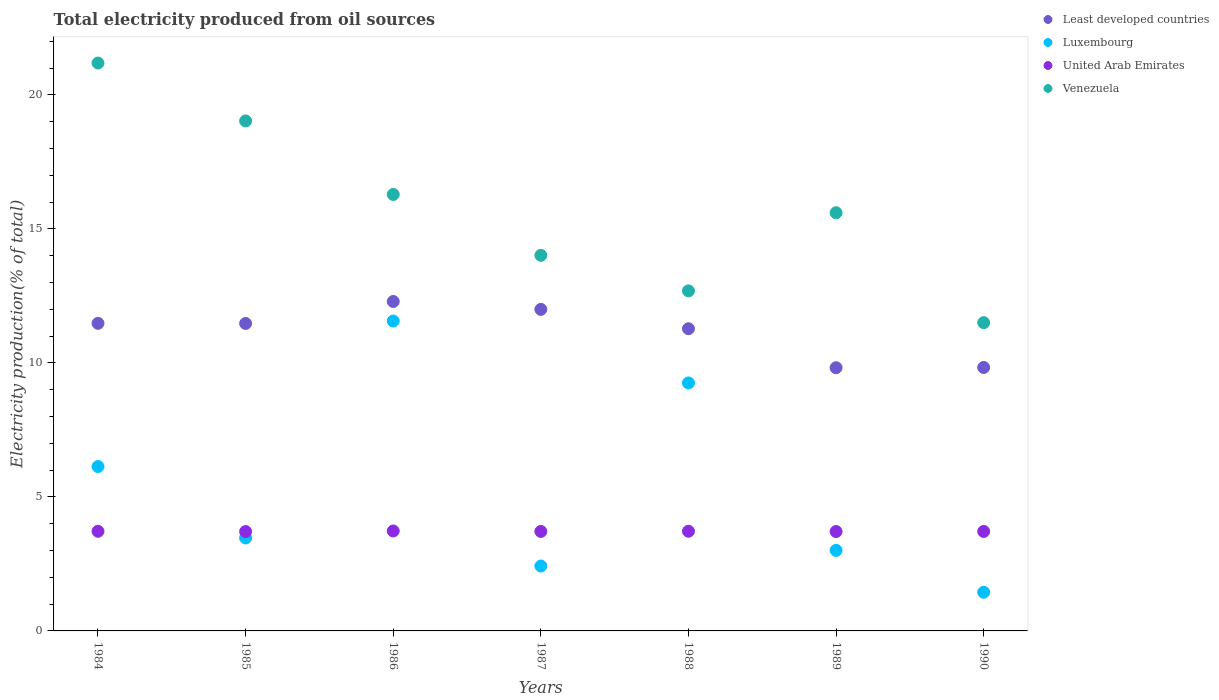What is the total electricity produced in Luxembourg in 1987?
Keep it short and to the point. 2.42. Across all years, what is the maximum total electricity produced in Luxembourg?
Make the answer very short. 11.56. Across all years, what is the minimum total electricity produced in Least developed countries?
Offer a terse response. 9.82. In which year was the total electricity produced in Least developed countries minimum?
Provide a succinct answer. 1989. What is the total total electricity produced in Luxembourg in the graph?
Offer a terse response. 37.29. What is the difference between the total electricity produced in Venezuela in 1984 and that in 1988?
Provide a short and direct response. 8.5. What is the difference between the total electricity produced in Least developed countries in 1985 and the total electricity produced in Venezuela in 1989?
Your answer should be compact. -4.13. What is the average total electricity produced in Venezuela per year?
Offer a terse response. 15.76. In the year 1986, what is the difference between the total electricity produced in Venezuela and total electricity produced in United Arab Emirates?
Your response must be concise. 12.56. What is the ratio of the total electricity produced in United Arab Emirates in 1984 to that in 1989?
Ensure brevity in your answer.  1. Is the difference between the total electricity produced in Venezuela in 1984 and 1990 greater than the difference between the total electricity produced in United Arab Emirates in 1984 and 1990?
Offer a terse response. Yes. What is the difference between the highest and the second highest total electricity produced in Luxembourg?
Your answer should be compact. 2.31. What is the difference between the highest and the lowest total electricity produced in Luxembourg?
Give a very brief answer. 10.12. In how many years, is the total electricity produced in Least developed countries greater than the average total electricity produced in Least developed countries taken over all years?
Ensure brevity in your answer.  5. Is the sum of the total electricity produced in Venezuela in 1985 and 1987 greater than the maximum total electricity produced in Luxembourg across all years?
Provide a short and direct response. Yes. Is it the case that in every year, the sum of the total electricity produced in United Arab Emirates and total electricity produced in Venezuela  is greater than the sum of total electricity produced in Luxembourg and total electricity produced in Least developed countries?
Your answer should be compact. Yes. Is it the case that in every year, the sum of the total electricity produced in Least developed countries and total electricity produced in Venezuela  is greater than the total electricity produced in United Arab Emirates?
Offer a very short reply. Yes. Does the total electricity produced in Venezuela monotonically increase over the years?
Your answer should be compact. No. Is the total electricity produced in Luxembourg strictly less than the total electricity produced in Least developed countries over the years?
Provide a succinct answer. Yes. How many dotlines are there?
Your answer should be very brief. 4. How many years are there in the graph?
Offer a very short reply. 7. What is the difference between two consecutive major ticks on the Y-axis?
Your response must be concise. 5. Does the graph contain any zero values?
Keep it short and to the point. No. What is the title of the graph?
Offer a very short reply. Total electricity produced from oil sources. What is the label or title of the Y-axis?
Offer a terse response. Electricity production(% of total). What is the Electricity production(% of total) in Least developed countries in 1984?
Make the answer very short. 11.48. What is the Electricity production(% of total) of Luxembourg in 1984?
Offer a very short reply. 6.13. What is the Electricity production(% of total) of United Arab Emirates in 1984?
Your answer should be compact. 3.72. What is the Electricity production(% of total) of Venezuela in 1984?
Your answer should be very brief. 21.19. What is the Electricity production(% of total) of Least developed countries in 1985?
Provide a succinct answer. 11.47. What is the Electricity production(% of total) of Luxembourg in 1985?
Provide a succinct answer. 3.47. What is the Electricity production(% of total) of United Arab Emirates in 1985?
Ensure brevity in your answer.  3.71. What is the Electricity production(% of total) of Venezuela in 1985?
Provide a succinct answer. 19.03. What is the Electricity production(% of total) of Least developed countries in 1986?
Ensure brevity in your answer.  12.29. What is the Electricity production(% of total) in Luxembourg in 1986?
Give a very brief answer. 11.56. What is the Electricity production(% of total) of United Arab Emirates in 1986?
Make the answer very short. 3.73. What is the Electricity production(% of total) of Venezuela in 1986?
Provide a succinct answer. 16.29. What is the Electricity production(% of total) of Least developed countries in 1987?
Ensure brevity in your answer.  12. What is the Electricity production(% of total) of Luxembourg in 1987?
Your answer should be very brief. 2.42. What is the Electricity production(% of total) of United Arab Emirates in 1987?
Your answer should be compact. 3.71. What is the Electricity production(% of total) of Venezuela in 1987?
Your answer should be very brief. 14.02. What is the Electricity production(% of total) in Least developed countries in 1988?
Provide a short and direct response. 11.28. What is the Electricity production(% of total) in Luxembourg in 1988?
Provide a short and direct response. 9.25. What is the Electricity production(% of total) in United Arab Emirates in 1988?
Make the answer very short. 3.72. What is the Electricity production(% of total) in Venezuela in 1988?
Your answer should be compact. 12.69. What is the Electricity production(% of total) of Least developed countries in 1989?
Make the answer very short. 9.82. What is the Electricity production(% of total) in Luxembourg in 1989?
Keep it short and to the point. 3.01. What is the Electricity production(% of total) of United Arab Emirates in 1989?
Make the answer very short. 3.71. What is the Electricity production(% of total) of Venezuela in 1989?
Ensure brevity in your answer.  15.61. What is the Electricity production(% of total) of Least developed countries in 1990?
Your answer should be very brief. 9.83. What is the Electricity production(% of total) in Luxembourg in 1990?
Offer a very short reply. 1.44. What is the Electricity production(% of total) of United Arab Emirates in 1990?
Make the answer very short. 3.71. What is the Electricity production(% of total) in Venezuela in 1990?
Your response must be concise. 11.5. Across all years, what is the maximum Electricity production(% of total) of Least developed countries?
Give a very brief answer. 12.29. Across all years, what is the maximum Electricity production(% of total) in Luxembourg?
Provide a short and direct response. 11.56. Across all years, what is the maximum Electricity production(% of total) of United Arab Emirates?
Your response must be concise. 3.73. Across all years, what is the maximum Electricity production(% of total) of Venezuela?
Provide a succinct answer. 21.19. Across all years, what is the minimum Electricity production(% of total) of Least developed countries?
Offer a terse response. 9.82. Across all years, what is the minimum Electricity production(% of total) of Luxembourg?
Ensure brevity in your answer.  1.44. Across all years, what is the minimum Electricity production(% of total) in United Arab Emirates?
Make the answer very short. 3.71. Across all years, what is the minimum Electricity production(% of total) in Venezuela?
Keep it short and to the point. 11.5. What is the total Electricity production(% of total) of Least developed countries in the graph?
Keep it short and to the point. 78.17. What is the total Electricity production(% of total) of Luxembourg in the graph?
Your answer should be very brief. 37.29. What is the total Electricity production(% of total) of United Arab Emirates in the graph?
Your response must be concise. 26.01. What is the total Electricity production(% of total) of Venezuela in the graph?
Your response must be concise. 110.33. What is the difference between the Electricity production(% of total) of Least developed countries in 1984 and that in 1985?
Your answer should be very brief. 0. What is the difference between the Electricity production(% of total) of Luxembourg in 1984 and that in 1985?
Provide a succinct answer. 2.67. What is the difference between the Electricity production(% of total) in United Arab Emirates in 1984 and that in 1985?
Provide a short and direct response. 0.01. What is the difference between the Electricity production(% of total) in Venezuela in 1984 and that in 1985?
Offer a very short reply. 2.16. What is the difference between the Electricity production(% of total) in Least developed countries in 1984 and that in 1986?
Offer a very short reply. -0.82. What is the difference between the Electricity production(% of total) in Luxembourg in 1984 and that in 1986?
Offer a terse response. -5.43. What is the difference between the Electricity production(% of total) in United Arab Emirates in 1984 and that in 1986?
Keep it short and to the point. -0.01. What is the difference between the Electricity production(% of total) in Venezuela in 1984 and that in 1986?
Offer a terse response. 4.9. What is the difference between the Electricity production(% of total) of Least developed countries in 1984 and that in 1987?
Your answer should be very brief. -0.52. What is the difference between the Electricity production(% of total) in Luxembourg in 1984 and that in 1987?
Your response must be concise. 3.71. What is the difference between the Electricity production(% of total) of United Arab Emirates in 1984 and that in 1987?
Ensure brevity in your answer.  0.01. What is the difference between the Electricity production(% of total) of Venezuela in 1984 and that in 1987?
Your answer should be very brief. 7.18. What is the difference between the Electricity production(% of total) of Least developed countries in 1984 and that in 1988?
Provide a succinct answer. 0.2. What is the difference between the Electricity production(% of total) in Luxembourg in 1984 and that in 1988?
Make the answer very short. -3.12. What is the difference between the Electricity production(% of total) of United Arab Emirates in 1984 and that in 1988?
Keep it short and to the point. -0. What is the difference between the Electricity production(% of total) in Venezuela in 1984 and that in 1988?
Ensure brevity in your answer.  8.5. What is the difference between the Electricity production(% of total) in Least developed countries in 1984 and that in 1989?
Provide a succinct answer. 1.66. What is the difference between the Electricity production(% of total) of Luxembourg in 1984 and that in 1989?
Ensure brevity in your answer.  3.13. What is the difference between the Electricity production(% of total) of United Arab Emirates in 1984 and that in 1989?
Offer a very short reply. 0.01. What is the difference between the Electricity production(% of total) of Venezuela in 1984 and that in 1989?
Your answer should be very brief. 5.59. What is the difference between the Electricity production(% of total) of Least developed countries in 1984 and that in 1990?
Provide a succinct answer. 1.65. What is the difference between the Electricity production(% of total) in Luxembourg in 1984 and that in 1990?
Give a very brief answer. 4.69. What is the difference between the Electricity production(% of total) in United Arab Emirates in 1984 and that in 1990?
Your answer should be very brief. 0.01. What is the difference between the Electricity production(% of total) in Venezuela in 1984 and that in 1990?
Your answer should be very brief. 9.69. What is the difference between the Electricity production(% of total) in Least developed countries in 1985 and that in 1986?
Ensure brevity in your answer.  -0.82. What is the difference between the Electricity production(% of total) in Luxembourg in 1985 and that in 1986?
Your answer should be compact. -8.1. What is the difference between the Electricity production(% of total) of United Arab Emirates in 1985 and that in 1986?
Provide a short and direct response. -0.02. What is the difference between the Electricity production(% of total) in Venezuela in 1985 and that in 1986?
Keep it short and to the point. 2.74. What is the difference between the Electricity production(% of total) of Least developed countries in 1985 and that in 1987?
Provide a succinct answer. -0.53. What is the difference between the Electricity production(% of total) of Luxembourg in 1985 and that in 1987?
Offer a very short reply. 1.05. What is the difference between the Electricity production(% of total) of United Arab Emirates in 1985 and that in 1987?
Offer a terse response. -0. What is the difference between the Electricity production(% of total) of Venezuela in 1985 and that in 1987?
Your answer should be compact. 5.02. What is the difference between the Electricity production(% of total) in Least developed countries in 1985 and that in 1988?
Offer a very short reply. 0.2. What is the difference between the Electricity production(% of total) of Luxembourg in 1985 and that in 1988?
Your response must be concise. -5.79. What is the difference between the Electricity production(% of total) in United Arab Emirates in 1985 and that in 1988?
Offer a terse response. -0.01. What is the difference between the Electricity production(% of total) in Venezuela in 1985 and that in 1988?
Provide a short and direct response. 6.34. What is the difference between the Electricity production(% of total) in Least developed countries in 1985 and that in 1989?
Provide a succinct answer. 1.65. What is the difference between the Electricity production(% of total) in Luxembourg in 1985 and that in 1989?
Provide a succinct answer. 0.46. What is the difference between the Electricity production(% of total) in United Arab Emirates in 1985 and that in 1989?
Offer a very short reply. -0. What is the difference between the Electricity production(% of total) of Venezuela in 1985 and that in 1989?
Your answer should be compact. 3.43. What is the difference between the Electricity production(% of total) of Least developed countries in 1985 and that in 1990?
Your response must be concise. 1.64. What is the difference between the Electricity production(% of total) of Luxembourg in 1985 and that in 1990?
Provide a short and direct response. 2.03. What is the difference between the Electricity production(% of total) of United Arab Emirates in 1985 and that in 1990?
Your answer should be compact. -0. What is the difference between the Electricity production(% of total) of Venezuela in 1985 and that in 1990?
Keep it short and to the point. 7.53. What is the difference between the Electricity production(% of total) of Least developed countries in 1986 and that in 1987?
Offer a very short reply. 0.3. What is the difference between the Electricity production(% of total) in Luxembourg in 1986 and that in 1987?
Offer a very short reply. 9.14. What is the difference between the Electricity production(% of total) of United Arab Emirates in 1986 and that in 1987?
Provide a succinct answer. 0.02. What is the difference between the Electricity production(% of total) in Venezuela in 1986 and that in 1987?
Your response must be concise. 2.27. What is the difference between the Electricity production(% of total) of Least developed countries in 1986 and that in 1988?
Provide a short and direct response. 1.02. What is the difference between the Electricity production(% of total) in Luxembourg in 1986 and that in 1988?
Offer a terse response. 2.31. What is the difference between the Electricity production(% of total) in United Arab Emirates in 1986 and that in 1988?
Ensure brevity in your answer.  0.01. What is the difference between the Electricity production(% of total) of Venezuela in 1986 and that in 1988?
Give a very brief answer. 3.6. What is the difference between the Electricity production(% of total) in Least developed countries in 1986 and that in 1989?
Your answer should be compact. 2.47. What is the difference between the Electricity production(% of total) in Luxembourg in 1986 and that in 1989?
Your response must be concise. 8.56. What is the difference between the Electricity production(% of total) of United Arab Emirates in 1986 and that in 1989?
Provide a short and direct response. 0.02. What is the difference between the Electricity production(% of total) in Venezuela in 1986 and that in 1989?
Your answer should be very brief. 0.68. What is the difference between the Electricity production(% of total) of Least developed countries in 1986 and that in 1990?
Offer a very short reply. 2.46. What is the difference between the Electricity production(% of total) in Luxembourg in 1986 and that in 1990?
Your answer should be compact. 10.12. What is the difference between the Electricity production(% of total) in United Arab Emirates in 1986 and that in 1990?
Your answer should be very brief. 0.02. What is the difference between the Electricity production(% of total) in Venezuela in 1986 and that in 1990?
Give a very brief answer. 4.78. What is the difference between the Electricity production(% of total) of Least developed countries in 1987 and that in 1988?
Offer a very short reply. 0.72. What is the difference between the Electricity production(% of total) in Luxembourg in 1987 and that in 1988?
Make the answer very short. -6.83. What is the difference between the Electricity production(% of total) in United Arab Emirates in 1987 and that in 1988?
Your response must be concise. -0.01. What is the difference between the Electricity production(% of total) of Venezuela in 1987 and that in 1988?
Make the answer very short. 1.33. What is the difference between the Electricity production(% of total) of Least developed countries in 1987 and that in 1989?
Offer a very short reply. 2.18. What is the difference between the Electricity production(% of total) of Luxembourg in 1987 and that in 1989?
Offer a terse response. -0.58. What is the difference between the Electricity production(% of total) in United Arab Emirates in 1987 and that in 1989?
Your response must be concise. 0. What is the difference between the Electricity production(% of total) in Venezuela in 1987 and that in 1989?
Offer a terse response. -1.59. What is the difference between the Electricity production(% of total) in Least developed countries in 1987 and that in 1990?
Offer a terse response. 2.17. What is the difference between the Electricity production(% of total) of Luxembourg in 1987 and that in 1990?
Keep it short and to the point. 0.98. What is the difference between the Electricity production(% of total) in Venezuela in 1987 and that in 1990?
Offer a terse response. 2.51. What is the difference between the Electricity production(% of total) of Least developed countries in 1988 and that in 1989?
Your answer should be very brief. 1.46. What is the difference between the Electricity production(% of total) in Luxembourg in 1988 and that in 1989?
Offer a very short reply. 6.25. What is the difference between the Electricity production(% of total) of United Arab Emirates in 1988 and that in 1989?
Give a very brief answer. 0.01. What is the difference between the Electricity production(% of total) of Venezuela in 1988 and that in 1989?
Make the answer very short. -2.92. What is the difference between the Electricity production(% of total) in Least developed countries in 1988 and that in 1990?
Your answer should be very brief. 1.45. What is the difference between the Electricity production(% of total) of Luxembourg in 1988 and that in 1990?
Your response must be concise. 7.81. What is the difference between the Electricity production(% of total) in United Arab Emirates in 1988 and that in 1990?
Keep it short and to the point. 0.01. What is the difference between the Electricity production(% of total) of Venezuela in 1988 and that in 1990?
Offer a terse response. 1.19. What is the difference between the Electricity production(% of total) of Least developed countries in 1989 and that in 1990?
Offer a terse response. -0.01. What is the difference between the Electricity production(% of total) of Luxembourg in 1989 and that in 1990?
Give a very brief answer. 1.56. What is the difference between the Electricity production(% of total) in United Arab Emirates in 1989 and that in 1990?
Provide a succinct answer. -0. What is the difference between the Electricity production(% of total) of Venezuela in 1989 and that in 1990?
Your answer should be very brief. 4.1. What is the difference between the Electricity production(% of total) of Least developed countries in 1984 and the Electricity production(% of total) of Luxembourg in 1985?
Give a very brief answer. 8.01. What is the difference between the Electricity production(% of total) in Least developed countries in 1984 and the Electricity production(% of total) in United Arab Emirates in 1985?
Offer a terse response. 7.77. What is the difference between the Electricity production(% of total) of Least developed countries in 1984 and the Electricity production(% of total) of Venezuela in 1985?
Your answer should be compact. -7.55. What is the difference between the Electricity production(% of total) in Luxembourg in 1984 and the Electricity production(% of total) in United Arab Emirates in 1985?
Your response must be concise. 2.43. What is the difference between the Electricity production(% of total) of Luxembourg in 1984 and the Electricity production(% of total) of Venezuela in 1985?
Ensure brevity in your answer.  -12.9. What is the difference between the Electricity production(% of total) of United Arab Emirates in 1984 and the Electricity production(% of total) of Venezuela in 1985?
Make the answer very short. -15.31. What is the difference between the Electricity production(% of total) of Least developed countries in 1984 and the Electricity production(% of total) of Luxembourg in 1986?
Keep it short and to the point. -0.09. What is the difference between the Electricity production(% of total) in Least developed countries in 1984 and the Electricity production(% of total) in United Arab Emirates in 1986?
Provide a succinct answer. 7.75. What is the difference between the Electricity production(% of total) in Least developed countries in 1984 and the Electricity production(% of total) in Venezuela in 1986?
Your answer should be compact. -4.81. What is the difference between the Electricity production(% of total) in Luxembourg in 1984 and the Electricity production(% of total) in United Arab Emirates in 1986?
Offer a very short reply. 2.4. What is the difference between the Electricity production(% of total) of Luxembourg in 1984 and the Electricity production(% of total) of Venezuela in 1986?
Your response must be concise. -10.15. What is the difference between the Electricity production(% of total) of United Arab Emirates in 1984 and the Electricity production(% of total) of Venezuela in 1986?
Your response must be concise. -12.57. What is the difference between the Electricity production(% of total) in Least developed countries in 1984 and the Electricity production(% of total) in Luxembourg in 1987?
Provide a short and direct response. 9.06. What is the difference between the Electricity production(% of total) in Least developed countries in 1984 and the Electricity production(% of total) in United Arab Emirates in 1987?
Provide a succinct answer. 7.77. What is the difference between the Electricity production(% of total) of Least developed countries in 1984 and the Electricity production(% of total) of Venezuela in 1987?
Provide a short and direct response. -2.54. What is the difference between the Electricity production(% of total) in Luxembourg in 1984 and the Electricity production(% of total) in United Arab Emirates in 1987?
Offer a terse response. 2.42. What is the difference between the Electricity production(% of total) of Luxembourg in 1984 and the Electricity production(% of total) of Venezuela in 1987?
Offer a very short reply. -7.88. What is the difference between the Electricity production(% of total) of United Arab Emirates in 1984 and the Electricity production(% of total) of Venezuela in 1987?
Your response must be concise. -10.3. What is the difference between the Electricity production(% of total) in Least developed countries in 1984 and the Electricity production(% of total) in Luxembourg in 1988?
Keep it short and to the point. 2.22. What is the difference between the Electricity production(% of total) of Least developed countries in 1984 and the Electricity production(% of total) of United Arab Emirates in 1988?
Provide a succinct answer. 7.76. What is the difference between the Electricity production(% of total) of Least developed countries in 1984 and the Electricity production(% of total) of Venezuela in 1988?
Provide a short and direct response. -1.21. What is the difference between the Electricity production(% of total) of Luxembourg in 1984 and the Electricity production(% of total) of United Arab Emirates in 1988?
Offer a terse response. 2.41. What is the difference between the Electricity production(% of total) in Luxembourg in 1984 and the Electricity production(% of total) in Venezuela in 1988?
Your answer should be very brief. -6.56. What is the difference between the Electricity production(% of total) of United Arab Emirates in 1984 and the Electricity production(% of total) of Venezuela in 1988?
Provide a succinct answer. -8.97. What is the difference between the Electricity production(% of total) in Least developed countries in 1984 and the Electricity production(% of total) in Luxembourg in 1989?
Provide a succinct answer. 8.47. What is the difference between the Electricity production(% of total) of Least developed countries in 1984 and the Electricity production(% of total) of United Arab Emirates in 1989?
Offer a terse response. 7.77. What is the difference between the Electricity production(% of total) in Least developed countries in 1984 and the Electricity production(% of total) in Venezuela in 1989?
Your response must be concise. -4.13. What is the difference between the Electricity production(% of total) in Luxembourg in 1984 and the Electricity production(% of total) in United Arab Emirates in 1989?
Ensure brevity in your answer.  2.43. What is the difference between the Electricity production(% of total) of Luxembourg in 1984 and the Electricity production(% of total) of Venezuela in 1989?
Give a very brief answer. -9.47. What is the difference between the Electricity production(% of total) in United Arab Emirates in 1984 and the Electricity production(% of total) in Venezuela in 1989?
Provide a short and direct response. -11.89. What is the difference between the Electricity production(% of total) of Least developed countries in 1984 and the Electricity production(% of total) of Luxembourg in 1990?
Your answer should be very brief. 10.04. What is the difference between the Electricity production(% of total) in Least developed countries in 1984 and the Electricity production(% of total) in United Arab Emirates in 1990?
Give a very brief answer. 7.77. What is the difference between the Electricity production(% of total) in Least developed countries in 1984 and the Electricity production(% of total) in Venezuela in 1990?
Offer a terse response. -0.03. What is the difference between the Electricity production(% of total) in Luxembourg in 1984 and the Electricity production(% of total) in United Arab Emirates in 1990?
Ensure brevity in your answer.  2.42. What is the difference between the Electricity production(% of total) of Luxembourg in 1984 and the Electricity production(% of total) of Venezuela in 1990?
Your answer should be very brief. -5.37. What is the difference between the Electricity production(% of total) of United Arab Emirates in 1984 and the Electricity production(% of total) of Venezuela in 1990?
Give a very brief answer. -7.79. What is the difference between the Electricity production(% of total) in Least developed countries in 1985 and the Electricity production(% of total) in Luxembourg in 1986?
Your answer should be compact. -0.09. What is the difference between the Electricity production(% of total) in Least developed countries in 1985 and the Electricity production(% of total) in United Arab Emirates in 1986?
Give a very brief answer. 7.74. What is the difference between the Electricity production(% of total) in Least developed countries in 1985 and the Electricity production(% of total) in Venezuela in 1986?
Offer a very short reply. -4.81. What is the difference between the Electricity production(% of total) of Luxembourg in 1985 and the Electricity production(% of total) of United Arab Emirates in 1986?
Your answer should be compact. -0.26. What is the difference between the Electricity production(% of total) in Luxembourg in 1985 and the Electricity production(% of total) in Venezuela in 1986?
Give a very brief answer. -12.82. What is the difference between the Electricity production(% of total) of United Arab Emirates in 1985 and the Electricity production(% of total) of Venezuela in 1986?
Make the answer very short. -12.58. What is the difference between the Electricity production(% of total) in Least developed countries in 1985 and the Electricity production(% of total) in Luxembourg in 1987?
Offer a terse response. 9.05. What is the difference between the Electricity production(% of total) of Least developed countries in 1985 and the Electricity production(% of total) of United Arab Emirates in 1987?
Provide a succinct answer. 7.76. What is the difference between the Electricity production(% of total) of Least developed countries in 1985 and the Electricity production(% of total) of Venezuela in 1987?
Provide a succinct answer. -2.54. What is the difference between the Electricity production(% of total) of Luxembourg in 1985 and the Electricity production(% of total) of United Arab Emirates in 1987?
Your answer should be very brief. -0.24. What is the difference between the Electricity production(% of total) in Luxembourg in 1985 and the Electricity production(% of total) in Venezuela in 1987?
Offer a terse response. -10.55. What is the difference between the Electricity production(% of total) of United Arab Emirates in 1985 and the Electricity production(% of total) of Venezuela in 1987?
Keep it short and to the point. -10.31. What is the difference between the Electricity production(% of total) of Least developed countries in 1985 and the Electricity production(% of total) of Luxembourg in 1988?
Make the answer very short. 2.22. What is the difference between the Electricity production(% of total) in Least developed countries in 1985 and the Electricity production(% of total) in United Arab Emirates in 1988?
Provide a succinct answer. 7.75. What is the difference between the Electricity production(% of total) in Least developed countries in 1985 and the Electricity production(% of total) in Venezuela in 1988?
Your answer should be compact. -1.22. What is the difference between the Electricity production(% of total) of Luxembourg in 1985 and the Electricity production(% of total) of United Arab Emirates in 1988?
Provide a short and direct response. -0.25. What is the difference between the Electricity production(% of total) of Luxembourg in 1985 and the Electricity production(% of total) of Venezuela in 1988?
Give a very brief answer. -9.22. What is the difference between the Electricity production(% of total) of United Arab Emirates in 1985 and the Electricity production(% of total) of Venezuela in 1988?
Make the answer very short. -8.98. What is the difference between the Electricity production(% of total) of Least developed countries in 1985 and the Electricity production(% of total) of Luxembourg in 1989?
Your answer should be very brief. 8.47. What is the difference between the Electricity production(% of total) of Least developed countries in 1985 and the Electricity production(% of total) of United Arab Emirates in 1989?
Provide a succinct answer. 7.76. What is the difference between the Electricity production(% of total) in Least developed countries in 1985 and the Electricity production(% of total) in Venezuela in 1989?
Your answer should be compact. -4.13. What is the difference between the Electricity production(% of total) in Luxembourg in 1985 and the Electricity production(% of total) in United Arab Emirates in 1989?
Make the answer very short. -0.24. What is the difference between the Electricity production(% of total) of Luxembourg in 1985 and the Electricity production(% of total) of Venezuela in 1989?
Your answer should be very brief. -12.14. What is the difference between the Electricity production(% of total) in United Arab Emirates in 1985 and the Electricity production(% of total) in Venezuela in 1989?
Keep it short and to the point. -11.9. What is the difference between the Electricity production(% of total) of Least developed countries in 1985 and the Electricity production(% of total) of Luxembourg in 1990?
Your response must be concise. 10.03. What is the difference between the Electricity production(% of total) in Least developed countries in 1985 and the Electricity production(% of total) in United Arab Emirates in 1990?
Keep it short and to the point. 7.76. What is the difference between the Electricity production(% of total) of Least developed countries in 1985 and the Electricity production(% of total) of Venezuela in 1990?
Provide a short and direct response. -0.03. What is the difference between the Electricity production(% of total) in Luxembourg in 1985 and the Electricity production(% of total) in United Arab Emirates in 1990?
Your answer should be compact. -0.24. What is the difference between the Electricity production(% of total) in Luxembourg in 1985 and the Electricity production(% of total) in Venezuela in 1990?
Make the answer very short. -8.04. What is the difference between the Electricity production(% of total) of United Arab Emirates in 1985 and the Electricity production(% of total) of Venezuela in 1990?
Ensure brevity in your answer.  -7.8. What is the difference between the Electricity production(% of total) of Least developed countries in 1986 and the Electricity production(% of total) of Luxembourg in 1987?
Your response must be concise. 9.87. What is the difference between the Electricity production(% of total) in Least developed countries in 1986 and the Electricity production(% of total) in United Arab Emirates in 1987?
Your answer should be compact. 8.58. What is the difference between the Electricity production(% of total) in Least developed countries in 1986 and the Electricity production(% of total) in Venezuela in 1987?
Keep it short and to the point. -1.72. What is the difference between the Electricity production(% of total) in Luxembourg in 1986 and the Electricity production(% of total) in United Arab Emirates in 1987?
Your response must be concise. 7.85. What is the difference between the Electricity production(% of total) of Luxembourg in 1986 and the Electricity production(% of total) of Venezuela in 1987?
Make the answer very short. -2.45. What is the difference between the Electricity production(% of total) of United Arab Emirates in 1986 and the Electricity production(% of total) of Venezuela in 1987?
Your answer should be very brief. -10.29. What is the difference between the Electricity production(% of total) of Least developed countries in 1986 and the Electricity production(% of total) of Luxembourg in 1988?
Give a very brief answer. 3.04. What is the difference between the Electricity production(% of total) of Least developed countries in 1986 and the Electricity production(% of total) of United Arab Emirates in 1988?
Your answer should be compact. 8.57. What is the difference between the Electricity production(% of total) in Least developed countries in 1986 and the Electricity production(% of total) in Venezuela in 1988?
Offer a very short reply. -0.4. What is the difference between the Electricity production(% of total) in Luxembourg in 1986 and the Electricity production(% of total) in United Arab Emirates in 1988?
Offer a very short reply. 7.84. What is the difference between the Electricity production(% of total) of Luxembourg in 1986 and the Electricity production(% of total) of Venezuela in 1988?
Provide a short and direct response. -1.12. What is the difference between the Electricity production(% of total) of United Arab Emirates in 1986 and the Electricity production(% of total) of Venezuela in 1988?
Your response must be concise. -8.96. What is the difference between the Electricity production(% of total) in Least developed countries in 1986 and the Electricity production(% of total) in Luxembourg in 1989?
Offer a terse response. 9.29. What is the difference between the Electricity production(% of total) in Least developed countries in 1986 and the Electricity production(% of total) in United Arab Emirates in 1989?
Keep it short and to the point. 8.59. What is the difference between the Electricity production(% of total) in Least developed countries in 1986 and the Electricity production(% of total) in Venezuela in 1989?
Your answer should be compact. -3.31. What is the difference between the Electricity production(% of total) of Luxembourg in 1986 and the Electricity production(% of total) of United Arab Emirates in 1989?
Provide a succinct answer. 7.86. What is the difference between the Electricity production(% of total) in Luxembourg in 1986 and the Electricity production(% of total) in Venezuela in 1989?
Provide a succinct answer. -4.04. What is the difference between the Electricity production(% of total) in United Arab Emirates in 1986 and the Electricity production(% of total) in Venezuela in 1989?
Ensure brevity in your answer.  -11.88. What is the difference between the Electricity production(% of total) in Least developed countries in 1986 and the Electricity production(% of total) in Luxembourg in 1990?
Give a very brief answer. 10.85. What is the difference between the Electricity production(% of total) of Least developed countries in 1986 and the Electricity production(% of total) of United Arab Emirates in 1990?
Offer a very short reply. 8.58. What is the difference between the Electricity production(% of total) in Least developed countries in 1986 and the Electricity production(% of total) in Venezuela in 1990?
Your answer should be very brief. 0.79. What is the difference between the Electricity production(% of total) of Luxembourg in 1986 and the Electricity production(% of total) of United Arab Emirates in 1990?
Offer a terse response. 7.85. What is the difference between the Electricity production(% of total) in Luxembourg in 1986 and the Electricity production(% of total) in Venezuela in 1990?
Your answer should be very brief. 0.06. What is the difference between the Electricity production(% of total) of United Arab Emirates in 1986 and the Electricity production(% of total) of Venezuela in 1990?
Keep it short and to the point. -7.77. What is the difference between the Electricity production(% of total) of Least developed countries in 1987 and the Electricity production(% of total) of Luxembourg in 1988?
Your response must be concise. 2.75. What is the difference between the Electricity production(% of total) of Least developed countries in 1987 and the Electricity production(% of total) of United Arab Emirates in 1988?
Offer a terse response. 8.28. What is the difference between the Electricity production(% of total) in Least developed countries in 1987 and the Electricity production(% of total) in Venezuela in 1988?
Provide a short and direct response. -0.69. What is the difference between the Electricity production(% of total) in Luxembourg in 1987 and the Electricity production(% of total) in United Arab Emirates in 1988?
Provide a short and direct response. -1.3. What is the difference between the Electricity production(% of total) in Luxembourg in 1987 and the Electricity production(% of total) in Venezuela in 1988?
Give a very brief answer. -10.27. What is the difference between the Electricity production(% of total) in United Arab Emirates in 1987 and the Electricity production(% of total) in Venezuela in 1988?
Give a very brief answer. -8.98. What is the difference between the Electricity production(% of total) of Least developed countries in 1987 and the Electricity production(% of total) of Luxembourg in 1989?
Provide a short and direct response. 8.99. What is the difference between the Electricity production(% of total) in Least developed countries in 1987 and the Electricity production(% of total) in United Arab Emirates in 1989?
Offer a very short reply. 8.29. What is the difference between the Electricity production(% of total) in Least developed countries in 1987 and the Electricity production(% of total) in Venezuela in 1989?
Your answer should be very brief. -3.61. What is the difference between the Electricity production(% of total) of Luxembourg in 1987 and the Electricity production(% of total) of United Arab Emirates in 1989?
Your answer should be very brief. -1.29. What is the difference between the Electricity production(% of total) in Luxembourg in 1987 and the Electricity production(% of total) in Venezuela in 1989?
Offer a very short reply. -13.18. What is the difference between the Electricity production(% of total) in United Arab Emirates in 1987 and the Electricity production(% of total) in Venezuela in 1989?
Your response must be concise. -11.89. What is the difference between the Electricity production(% of total) of Least developed countries in 1987 and the Electricity production(% of total) of Luxembourg in 1990?
Your answer should be compact. 10.56. What is the difference between the Electricity production(% of total) in Least developed countries in 1987 and the Electricity production(% of total) in United Arab Emirates in 1990?
Make the answer very short. 8.29. What is the difference between the Electricity production(% of total) in Least developed countries in 1987 and the Electricity production(% of total) in Venezuela in 1990?
Provide a succinct answer. 0.5. What is the difference between the Electricity production(% of total) in Luxembourg in 1987 and the Electricity production(% of total) in United Arab Emirates in 1990?
Offer a terse response. -1.29. What is the difference between the Electricity production(% of total) of Luxembourg in 1987 and the Electricity production(% of total) of Venezuela in 1990?
Keep it short and to the point. -9.08. What is the difference between the Electricity production(% of total) in United Arab Emirates in 1987 and the Electricity production(% of total) in Venezuela in 1990?
Provide a succinct answer. -7.79. What is the difference between the Electricity production(% of total) in Least developed countries in 1988 and the Electricity production(% of total) in Luxembourg in 1989?
Your response must be concise. 8.27. What is the difference between the Electricity production(% of total) in Least developed countries in 1988 and the Electricity production(% of total) in United Arab Emirates in 1989?
Your answer should be very brief. 7.57. What is the difference between the Electricity production(% of total) in Least developed countries in 1988 and the Electricity production(% of total) in Venezuela in 1989?
Ensure brevity in your answer.  -4.33. What is the difference between the Electricity production(% of total) of Luxembourg in 1988 and the Electricity production(% of total) of United Arab Emirates in 1989?
Make the answer very short. 5.54. What is the difference between the Electricity production(% of total) of Luxembourg in 1988 and the Electricity production(% of total) of Venezuela in 1989?
Provide a succinct answer. -6.35. What is the difference between the Electricity production(% of total) in United Arab Emirates in 1988 and the Electricity production(% of total) in Venezuela in 1989?
Your response must be concise. -11.89. What is the difference between the Electricity production(% of total) of Least developed countries in 1988 and the Electricity production(% of total) of Luxembourg in 1990?
Your answer should be compact. 9.83. What is the difference between the Electricity production(% of total) in Least developed countries in 1988 and the Electricity production(% of total) in United Arab Emirates in 1990?
Your answer should be very brief. 7.57. What is the difference between the Electricity production(% of total) in Least developed countries in 1988 and the Electricity production(% of total) in Venezuela in 1990?
Your response must be concise. -0.23. What is the difference between the Electricity production(% of total) in Luxembourg in 1988 and the Electricity production(% of total) in United Arab Emirates in 1990?
Offer a very short reply. 5.54. What is the difference between the Electricity production(% of total) in Luxembourg in 1988 and the Electricity production(% of total) in Venezuela in 1990?
Ensure brevity in your answer.  -2.25. What is the difference between the Electricity production(% of total) of United Arab Emirates in 1988 and the Electricity production(% of total) of Venezuela in 1990?
Your response must be concise. -7.78. What is the difference between the Electricity production(% of total) of Least developed countries in 1989 and the Electricity production(% of total) of Luxembourg in 1990?
Ensure brevity in your answer.  8.38. What is the difference between the Electricity production(% of total) of Least developed countries in 1989 and the Electricity production(% of total) of United Arab Emirates in 1990?
Provide a succinct answer. 6.11. What is the difference between the Electricity production(% of total) in Least developed countries in 1989 and the Electricity production(% of total) in Venezuela in 1990?
Your response must be concise. -1.68. What is the difference between the Electricity production(% of total) of Luxembourg in 1989 and the Electricity production(% of total) of United Arab Emirates in 1990?
Provide a short and direct response. -0.71. What is the difference between the Electricity production(% of total) of Luxembourg in 1989 and the Electricity production(% of total) of Venezuela in 1990?
Your answer should be compact. -8.5. What is the difference between the Electricity production(% of total) in United Arab Emirates in 1989 and the Electricity production(% of total) in Venezuela in 1990?
Your response must be concise. -7.79. What is the average Electricity production(% of total) of Least developed countries per year?
Offer a very short reply. 11.17. What is the average Electricity production(% of total) of Luxembourg per year?
Your response must be concise. 5.33. What is the average Electricity production(% of total) in United Arab Emirates per year?
Provide a succinct answer. 3.72. What is the average Electricity production(% of total) in Venezuela per year?
Your answer should be compact. 15.76. In the year 1984, what is the difference between the Electricity production(% of total) of Least developed countries and Electricity production(% of total) of Luxembourg?
Make the answer very short. 5.34. In the year 1984, what is the difference between the Electricity production(% of total) in Least developed countries and Electricity production(% of total) in United Arab Emirates?
Your answer should be very brief. 7.76. In the year 1984, what is the difference between the Electricity production(% of total) in Least developed countries and Electricity production(% of total) in Venezuela?
Your answer should be compact. -9.71. In the year 1984, what is the difference between the Electricity production(% of total) of Luxembourg and Electricity production(% of total) of United Arab Emirates?
Your answer should be compact. 2.42. In the year 1984, what is the difference between the Electricity production(% of total) of Luxembourg and Electricity production(% of total) of Venezuela?
Your response must be concise. -15.06. In the year 1984, what is the difference between the Electricity production(% of total) in United Arab Emirates and Electricity production(% of total) in Venezuela?
Your response must be concise. -17.47. In the year 1985, what is the difference between the Electricity production(% of total) in Least developed countries and Electricity production(% of total) in Luxembourg?
Offer a terse response. 8.01. In the year 1985, what is the difference between the Electricity production(% of total) of Least developed countries and Electricity production(% of total) of United Arab Emirates?
Give a very brief answer. 7.77. In the year 1985, what is the difference between the Electricity production(% of total) in Least developed countries and Electricity production(% of total) in Venezuela?
Your response must be concise. -7.56. In the year 1985, what is the difference between the Electricity production(% of total) of Luxembourg and Electricity production(% of total) of United Arab Emirates?
Give a very brief answer. -0.24. In the year 1985, what is the difference between the Electricity production(% of total) of Luxembourg and Electricity production(% of total) of Venezuela?
Your answer should be compact. -15.56. In the year 1985, what is the difference between the Electricity production(% of total) in United Arab Emirates and Electricity production(% of total) in Venezuela?
Provide a succinct answer. -15.32. In the year 1986, what is the difference between the Electricity production(% of total) in Least developed countries and Electricity production(% of total) in Luxembourg?
Provide a succinct answer. 0.73. In the year 1986, what is the difference between the Electricity production(% of total) in Least developed countries and Electricity production(% of total) in United Arab Emirates?
Ensure brevity in your answer.  8.56. In the year 1986, what is the difference between the Electricity production(% of total) of Least developed countries and Electricity production(% of total) of Venezuela?
Offer a terse response. -3.99. In the year 1986, what is the difference between the Electricity production(% of total) in Luxembourg and Electricity production(% of total) in United Arab Emirates?
Your answer should be compact. 7.83. In the year 1986, what is the difference between the Electricity production(% of total) in Luxembourg and Electricity production(% of total) in Venezuela?
Your answer should be very brief. -4.72. In the year 1986, what is the difference between the Electricity production(% of total) of United Arab Emirates and Electricity production(% of total) of Venezuela?
Provide a short and direct response. -12.56. In the year 1987, what is the difference between the Electricity production(% of total) of Least developed countries and Electricity production(% of total) of Luxembourg?
Ensure brevity in your answer.  9.58. In the year 1987, what is the difference between the Electricity production(% of total) of Least developed countries and Electricity production(% of total) of United Arab Emirates?
Give a very brief answer. 8.29. In the year 1987, what is the difference between the Electricity production(% of total) in Least developed countries and Electricity production(% of total) in Venezuela?
Offer a terse response. -2.02. In the year 1987, what is the difference between the Electricity production(% of total) of Luxembourg and Electricity production(% of total) of United Arab Emirates?
Offer a terse response. -1.29. In the year 1987, what is the difference between the Electricity production(% of total) of Luxembourg and Electricity production(% of total) of Venezuela?
Your answer should be very brief. -11.59. In the year 1987, what is the difference between the Electricity production(% of total) in United Arab Emirates and Electricity production(% of total) in Venezuela?
Provide a short and direct response. -10.3. In the year 1988, what is the difference between the Electricity production(% of total) of Least developed countries and Electricity production(% of total) of Luxembourg?
Your answer should be very brief. 2.02. In the year 1988, what is the difference between the Electricity production(% of total) in Least developed countries and Electricity production(% of total) in United Arab Emirates?
Give a very brief answer. 7.56. In the year 1988, what is the difference between the Electricity production(% of total) in Least developed countries and Electricity production(% of total) in Venezuela?
Provide a short and direct response. -1.41. In the year 1988, what is the difference between the Electricity production(% of total) of Luxembourg and Electricity production(% of total) of United Arab Emirates?
Your response must be concise. 5.53. In the year 1988, what is the difference between the Electricity production(% of total) of Luxembourg and Electricity production(% of total) of Venezuela?
Provide a succinct answer. -3.44. In the year 1988, what is the difference between the Electricity production(% of total) in United Arab Emirates and Electricity production(% of total) in Venezuela?
Make the answer very short. -8.97. In the year 1989, what is the difference between the Electricity production(% of total) in Least developed countries and Electricity production(% of total) in Luxembourg?
Ensure brevity in your answer.  6.82. In the year 1989, what is the difference between the Electricity production(% of total) of Least developed countries and Electricity production(% of total) of United Arab Emirates?
Keep it short and to the point. 6.11. In the year 1989, what is the difference between the Electricity production(% of total) in Least developed countries and Electricity production(% of total) in Venezuela?
Provide a short and direct response. -5.78. In the year 1989, what is the difference between the Electricity production(% of total) of Luxembourg and Electricity production(% of total) of United Arab Emirates?
Your response must be concise. -0.7. In the year 1989, what is the difference between the Electricity production(% of total) in Luxembourg and Electricity production(% of total) in Venezuela?
Offer a very short reply. -12.6. In the year 1989, what is the difference between the Electricity production(% of total) of United Arab Emirates and Electricity production(% of total) of Venezuela?
Keep it short and to the point. -11.9. In the year 1990, what is the difference between the Electricity production(% of total) of Least developed countries and Electricity production(% of total) of Luxembourg?
Keep it short and to the point. 8.39. In the year 1990, what is the difference between the Electricity production(% of total) in Least developed countries and Electricity production(% of total) in United Arab Emirates?
Offer a very short reply. 6.12. In the year 1990, what is the difference between the Electricity production(% of total) of Least developed countries and Electricity production(% of total) of Venezuela?
Your response must be concise. -1.67. In the year 1990, what is the difference between the Electricity production(% of total) in Luxembourg and Electricity production(% of total) in United Arab Emirates?
Ensure brevity in your answer.  -2.27. In the year 1990, what is the difference between the Electricity production(% of total) of Luxembourg and Electricity production(% of total) of Venezuela?
Your answer should be very brief. -10.06. In the year 1990, what is the difference between the Electricity production(% of total) in United Arab Emirates and Electricity production(% of total) in Venezuela?
Your answer should be compact. -7.79. What is the ratio of the Electricity production(% of total) of Least developed countries in 1984 to that in 1985?
Give a very brief answer. 1. What is the ratio of the Electricity production(% of total) of Luxembourg in 1984 to that in 1985?
Give a very brief answer. 1.77. What is the ratio of the Electricity production(% of total) in United Arab Emirates in 1984 to that in 1985?
Your response must be concise. 1. What is the ratio of the Electricity production(% of total) of Venezuela in 1984 to that in 1985?
Make the answer very short. 1.11. What is the ratio of the Electricity production(% of total) in Least developed countries in 1984 to that in 1986?
Offer a very short reply. 0.93. What is the ratio of the Electricity production(% of total) in Luxembourg in 1984 to that in 1986?
Give a very brief answer. 0.53. What is the ratio of the Electricity production(% of total) in Venezuela in 1984 to that in 1986?
Your response must be concise. 1.3. What is the ratio of the Electricity production(% of total) in Least developed countries in 1984 to that in 1987?
Your answer should be compact. 0.96. What is the ratio of the Electricity production(% of total) in Luxembourg in 1984 to that in 1987?
Give a very brief answer. 2.53. What is the ratio of the Electricity production(% of total) in Venezuela in 1984 to that in 1987?
Offer a terse response. 1.51. What is the ratio of the Electricity production(% of total) of Least developed countries in 1984 to that in 1988?
Make the answer very short. 1.02. What is the ratio of the Electricity production(% of total) of Luxembourg in 1984 to that in 1988?
Your answer should be very brief. 0.66. What is the ratio of the Electricity production(% of total) in Venezuela in 1984 to that in 1988?
Make the answer very short. 1.67. What is the ratio of the Electricity production(% of total) of Least developed countries in 1984 to that in 1989?
Keep it short and to the point. 1.17. What is the ratio of the Electricity production(% of total) in Luxembourg in 1984 to that in 1989?
Your answer should be compact. 2.04. What is the ratio of the Electricity production(% of total) of Venezuela in 1984 to that in 1989?
Offer a terse response. 1.36. What is the ratio of the Electricity production(% of total) of Least developed countries in 1984 to that in 1990?
Provide a succinct answer. 1.17. What is the ratio of the Electricity production(% of total) in Luxembourg in 1984 to that in 1990?
Offer a very short reply. 4.25. What is the ratio of the Electricity production(% of total) in Venezuela in 1984 to that in 1990?
Your answer should be compact. 1.84. What is the ratio of the Electricity production(% of total) of Least developed countries in 1985 to that in 1986?
Ensure brevity in your answer.  0.93. What is the ratio of the Electricity production(% of total) in Luxembourg in 1985 to that in 1986?
Offer a very short reply. 0.3. What is the ratio of the Electricity production(% of total) of Venezuela in 1985 to that in 1986?
Give a very brief answer. 1.17. What is the ratio of the Electricity production(% of total) in Least developed countries in 1985 to that in 1987?
Your response must be concise. 0.96. What is the ratio of the Electricity production(% of total) of Luxembourg in 1985 to that in 1987?
Provide a succinct answer. 1.43. What is the ratio of the Electricity production(% of total) of Venezuela in 1985 to that in 1987?
Offer a terse response. 1.36. What is the ratio of the Electricity production(% of total) in Least developed countries in 1985 to that in 1988?
Your answer should be compact. 1.02. What is the ratio of the Electricity production(% of total) of Luxembourg in 1985 to that in 1988?
Provide a short and direct response. 0.37. What is the ratio of the Electricity production(% of total) of Venezuela in 1985 to that in 1988?
Your answer should be very brief. 1.5. What is the ratio of the Electricity production(% of total) in Least developed countries in 1985 to that in 1989?
Your answer should be compact. 1.17. What is the ratio of the Electricity production(% of total) in Luxembourg in 1985 to that in 1989?
Your answer should be compact. 1.15. What is the ratio of the Electricity production(% of total) in United Arab Emirates in 1985 to that in 1989?
Your response must be concise. 1. What is the ratio of the Electricity production(% of total) in Venezuela in 1985 to that in 1989?
Your answer should be very brief. 1.22. What is the ratio of the Electricity production(% of total) in Least developed countries in 1985 to that in 1990?
Your answer should be very brief. 1.17. What is the ratio of the Electricity production(% of total) in Luxembourg in 1985 to that in 1990?
Offer a terse response. 2.4. What is the ratio of the Electricity production(% of total) of United Arab Emirates in 1985 to that in 1990?
Ensure brevity in your answer.  1. What is the ratio of the Electricity production(% of total) of Venezuela in 1985 to that in 1990?
Make the answer very short. 1.65. What is the ratio of the Electricity production(% of total) of Least developed countries in 1986 to that in 1987?
Keep it short and to the point. 1.02. What is the ratio of the Electricity production(% of total) of Luxembourg in 1986 to that in 1987?
Ensure brevity in your answer.  4.77. What is the ratio of the Electricity production(% of total) in Venezuela in 1986 to that in 1987?
Your answer should be very brief. 1.16. What is the ratio of the Electricity production(% of total) of Least developed countries in 1986 to that in 1988?
Your answer should be very brief. 1.09. What is the ratio of the Electricity production(% of total) in Luxembourg in 1986 to that in 1988?
Keep it short and to the point. 1.25. What is the ratio of the Electricity production(% of total) of Venezuela in 1986 to that in 1988?
Keep it short and to the point. 1.28. What is the ratio of the Electricity production(% of total) in Least developed countries in 1986 to that in 1989?
Offer a very short reply. 1.25. What is the ratio of the Electricity production(% of total) in Luxembourg in 1986 to that in 1989?
Provide a short and direct response. 3.85. What is the ratio of the Electricity production(% of total) in Venezuela in 1986 to that in 1989?
Your answer should be compact. 1.04. What is the ratio of the Electricity production(% of total) in Least developed countries in 1986 to that in 1990?
Your answer should be very brief. 1.25. What is the ratio of the Electricity production(% of total) of Luxembourg in 1986 to that in 1990?
Keep it short and to the point. 8.02. What is the ratio of the Electricity production(% of total) of Venezuela in 1986 to that in 1990?
Keep it short and to the point. 1.42. What is the ratio of the Electricity production(% of total) in Least developed countries in 1987 to that in 1988?
Provide a succinct answer. 1.06. What is the ratio of the Electricity production(% of total) of Luxembourg in 1987 to that in 1988?
Ensure brevity in your answer.  0.26. What is the ratio of the Electricity production(% of total) of Venezuela in 1987 to that in 1988?
Make the answer very short. 1.1. What is the ratio of the Electricity production(% of total) of Least developed countries in 1987 to that in 1989?
Offer a very short reply. 1.22. What is the ratio of the Electricity production(% of total) in Luxembourg in 1987 to that in 1989?
Give a very brief answer. 0.81. What is the ratio of the Electricity production(% of total) in Venezuela in 1987 to that in 1989?
Make the answer very short. 0.9. What is the ratio of the Electricity production(% of total) of Least developed countries in 1987 to that in 1990?
Offer a very short reply. 1.22. What is the ratio of the Electricity production(% of total) in Luxembourg in 1987 to that in 1990?
Ensure brevity in your answer.  1.68. What is the ratio of the Electricity production(% of total) in Venezuela in 1987 to that in 1990?
Offer a very short reply. 1.22. What is the ratio of the Electricity production(% of total) of Least developed countries in 1988 to that in 1989?
Your answer should be compact. 1.15. What is the ratio of the Electricity production(% of total) in Luxembourg in 1988 to that in 1989?
Provide a short and direct response. 3.08. What is the ratio of the Electricity production(% of total) of Venezuela in 1988 to that in 1989?
Offer a terse response. 0.81. What is the ratio of the Electricity production(% of total) of Least developed countries in 1988 to that in 1990?
Offer a very short reply. 1.15. What is the ratio of the Electricity production(% of total) of Luxembourg in 1988 to that in 1990?
Keep it short and to the point. 6.42. What is the ratio of the Electricity production(% of total) in Venezuela in 1988 to that in 1990?
Provide a short and direct response. 1.1. What is the ratio of the Electricity production(% of total) in Least developed countries in 1989 to that in 1990?
Your answer should be compact. 1. What is the ratio of the Electricity production(% of total) of Luxembourg in 1989 to that in 1990?
Your answer should be very brief. 2.08. What is the ratio of the Electricity production(% of total) of Venezuela in 1989 to that in 1990?
Offer a terse response. 1.36. What is the difference between the highest and the second highest Electricity production(% of total) of Least developed countries?
Keep it short and to the point. 0.3. What is the difference between the highest and the second highest Electricity production(% of total) of Luxembourg?
Your response must be concise. 2.31. What is the difference between the highest and the second highest Electricity production(% of total) of United Arab Emirates?
Your answer should be very brief. 0.01. What is the difference between the highest and the second highest Electricity production(% of total) in Venezuela?
Ensure brevity in your answer.  2.16. What is the difference between the highest and the lowest Electricity production(% of total) in Least developed countries?
Make the answer very short. 2.47. What is the difference between the highest and the lowest Electricity production(% of total) in Luxembourg?
Provide a succinct answer. 10.12. What is the difference between the highest and the lowest Electricity production(% of total) in United Arab Emirates?
Provide a succinct answer. 0.02. What is the difference between the highest and the lowest Electricity production(% of total) in Venezuela?
Your answer should be compact. 9.69. 